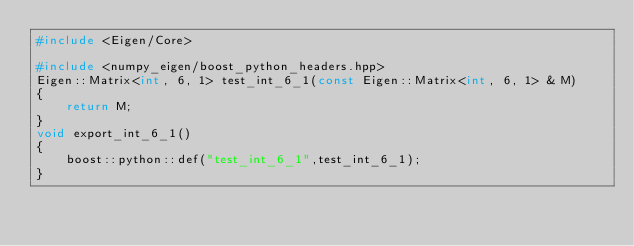<code> <loc_0><loc_0><loc_500><loc_500><_C++_>#include <Eigen/Core>

#include <numpy_eigen/boost_python_headers.hpp>
Eigen::Matrix<int, 6, 1> test_int_6_1(const Eigen::Matrix<int, 6, 1> & M)
{
	return M;
}
void export_int_6_1()
{
	boost::python::def("test_int_6_1",test_int_6_1);
}

</code> 